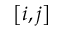Convert formula to latex. <formula><loc_0><loc_0><loc_500><loc_500>\left [ i , j \right ]</formula> 